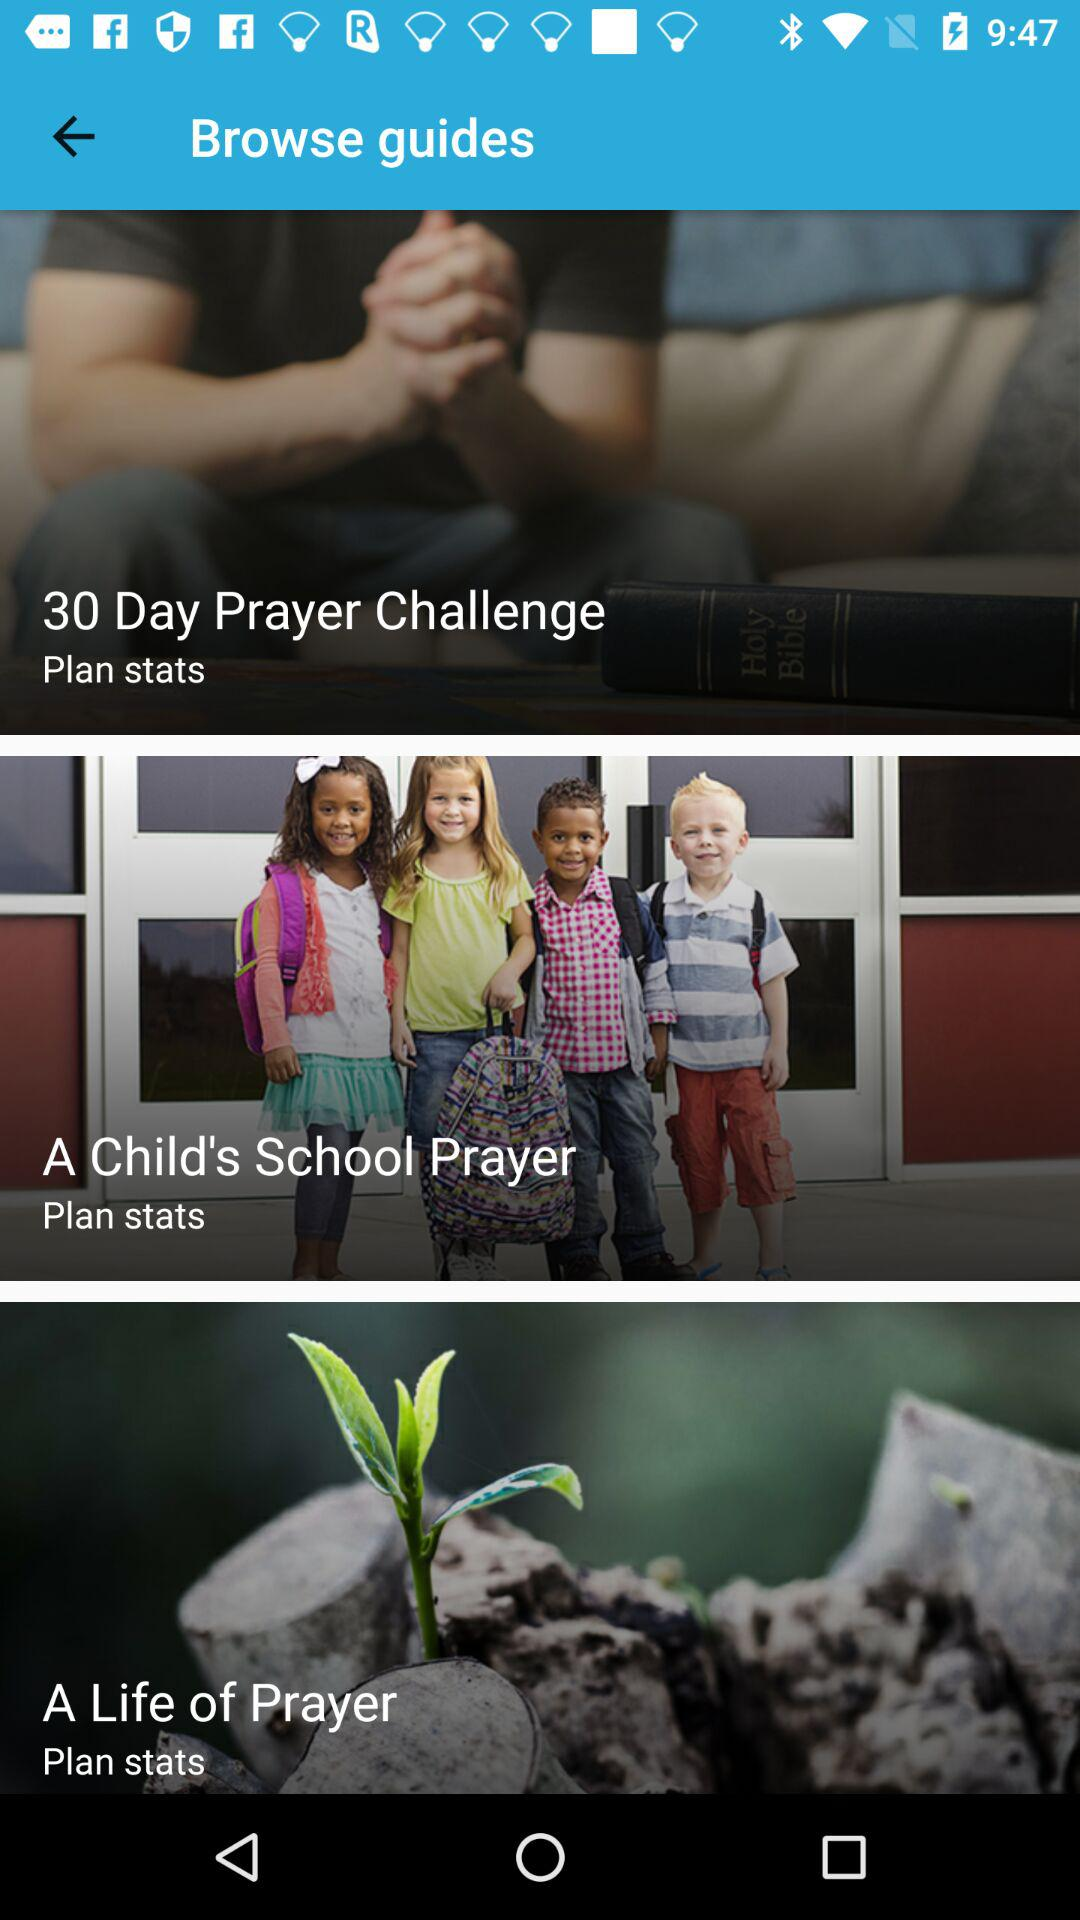What are the different browse guides? The different browse guides are "30 Day Prayer Challenge", "A Child's School Prayer" and "A Life of Prayer". 